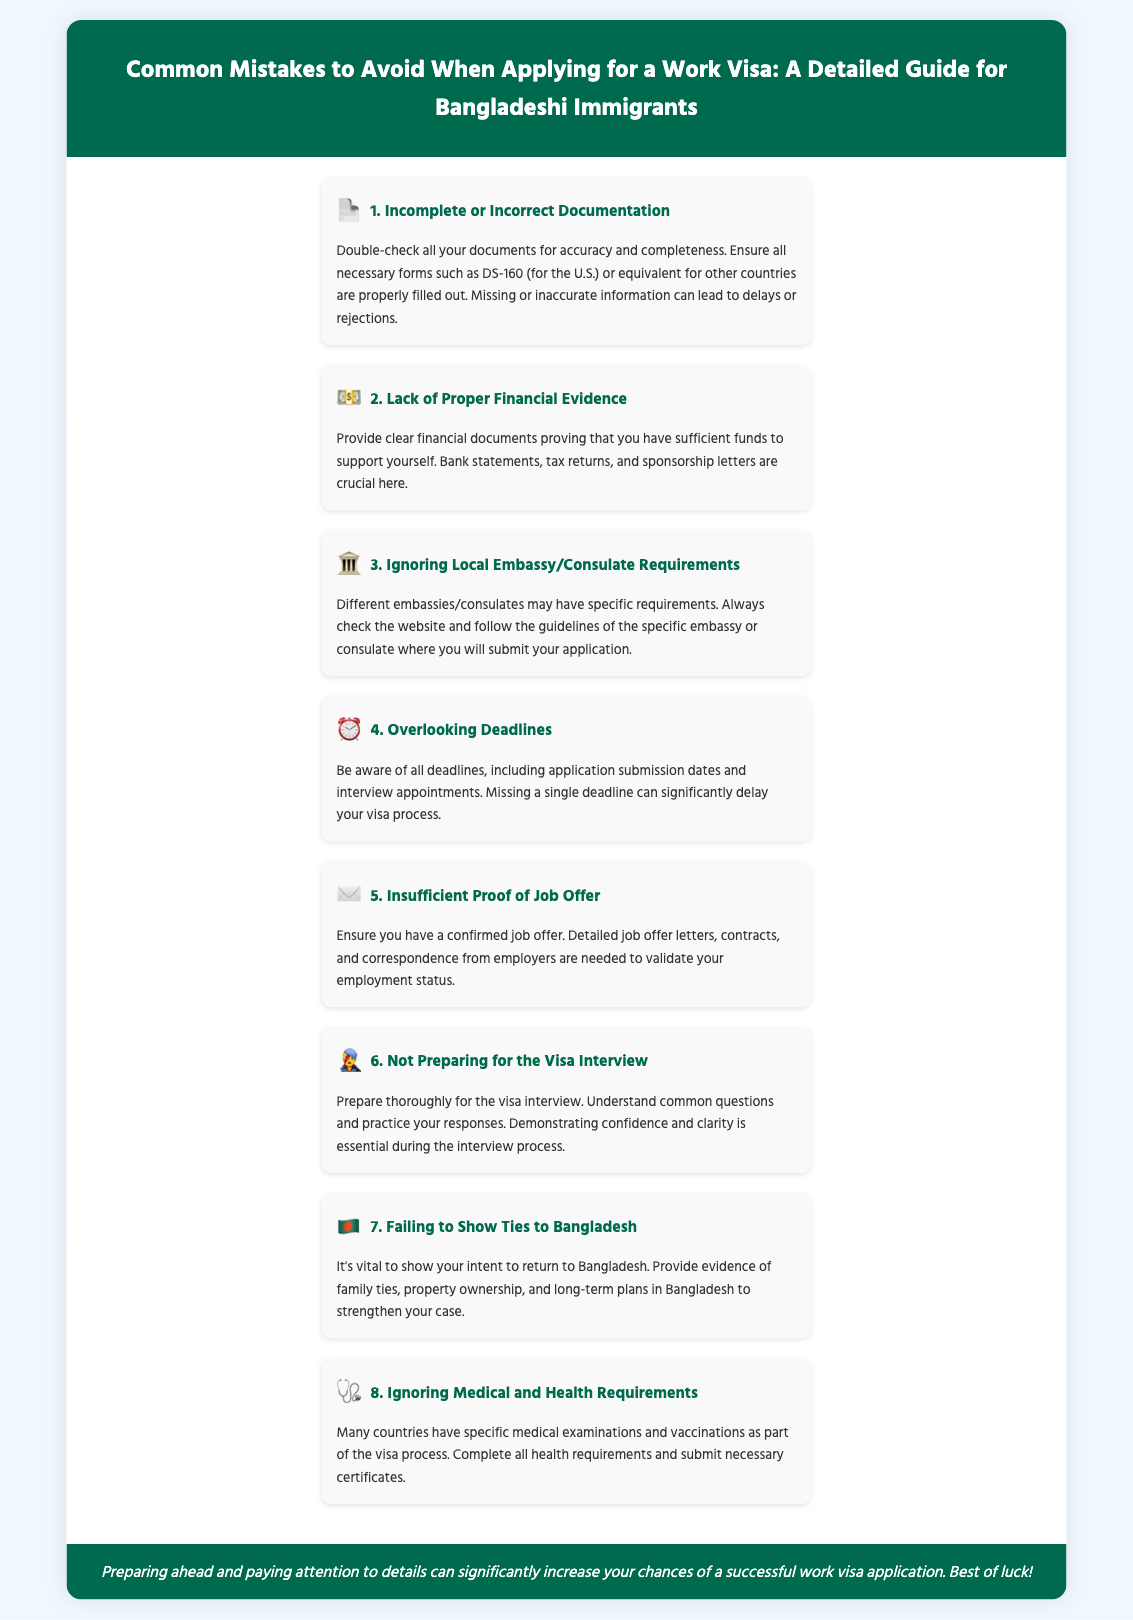what is the first common mistake listed? The first mistake mentioned in the document is about incomplete or incorrect documentation.
Answer: Incomplete or Incorrect Documentation what financial documents should be provided? The document states the importance of providing bank statements, tax returns, and sponsorship letters.
Answer: Bank statements, tax returns, sponsorship letters which country's visa application form is mentioned? The document specifically mentions the DS-160 form required for U.S. visa applications.
Answer: DS-160 what is advised to show regarding ties to Bangladesh? The document advises providing evidence of family ties, property ownership, and long-term plans in Bangladesh.
Answer: Family ties, property ownership, long-term plans why is preparing for the visa interview essential? The document highlights that demonstrating confidence and clarity during the interview is crucial.
Answer: Confidence and clarity how many common mistakes are detailed in the infographic? The document details a total of eight common mistakes to avoid when applying for a work visa.
Answer: Eight which section emphasizes deadlines? The section detailing the importance of being aware of deadlines is labeled "Overlooking Deadlines."
Answer: Overlooking Deadlines what type of examination is mentioned in relation to health requirements? The document refers to specific medical examinations as part of the visa process.
Answer: Medical examinations 